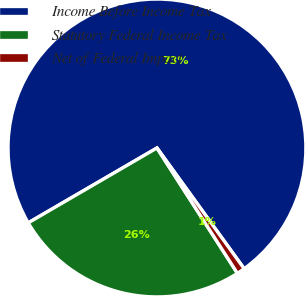<chart> <loc_0><loc_0><loc_500><loc_500><pie_chart><fcel>Income Before Income Tax<fcel>Statutory Federal Income Tax<fcel>Net of Federal Impact<nl><fcel>73.43%<fcel>25.7%<fcel>0.87%<nl></chart> 